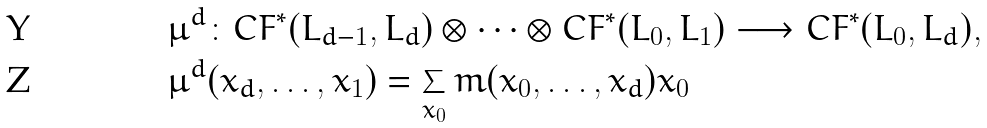<formula> <loc_0><loc_0><loc_500><loc_500>& \mu ^ { d } \colon C F ^ { * } ( L _ { d - 1 } , L _ { d } ) \otimes \cdots \otimes C F ^ { * } ( L _ { 0 } , L _ { 1 } ) \longrightarrow C F ^ { * } ( L _ { 0 } , L _ { d } ) , \\ & \mu ^ { d } ( x _ { d } , \dots , x _ { 1 } ) = \sum _ { x _ { 0 } } m ( x _ { 0 } , \dots , x _ { d } ) x _ { 0 }</formula> 